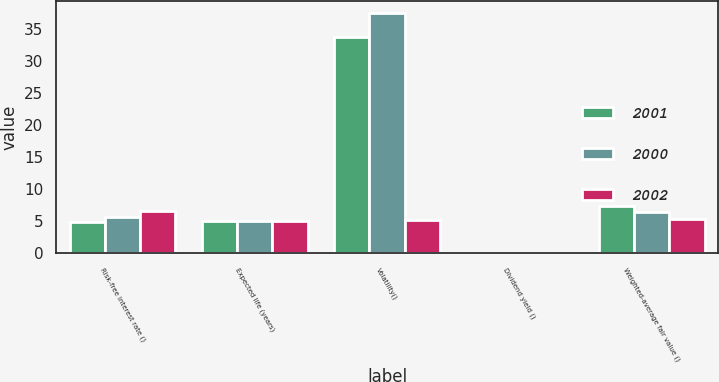<chart> <loc_0><loc_0><loc_500><loc_500><stacked_bar_chart><ecel><fcel>Risk-free interest rate ()<fcel>Expected life (years)<fcel>Volatility()<fcel>Dividend yield ()<fcel>Weighted-average fair value ()<nl><fcel>2001<fcel>4.85<fcel>5<fcel>33.8<fcel>0<fcel>7.45<nl><fcel>2000<fcel>5.67<fcel>5<fcel>37.5<fcel>0<fcel>6.52<nl><fcel>2002<fcel>6.68<fcel>5<fcel>5.18<fcel>0<fcel>5.36<nl></chart> 